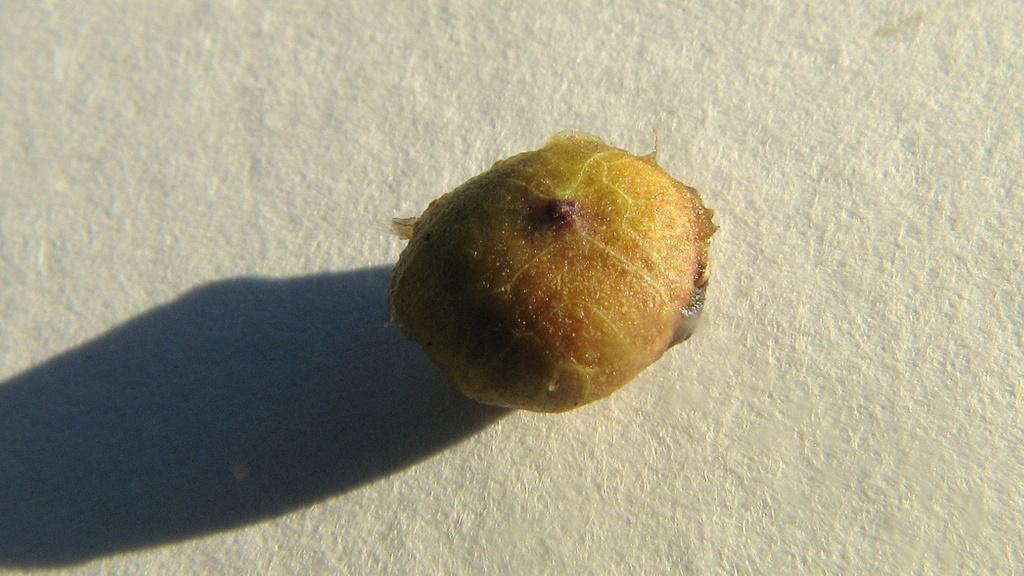How would you summarize this image in a sentence or two? In this image we can see an object with a white color background. 